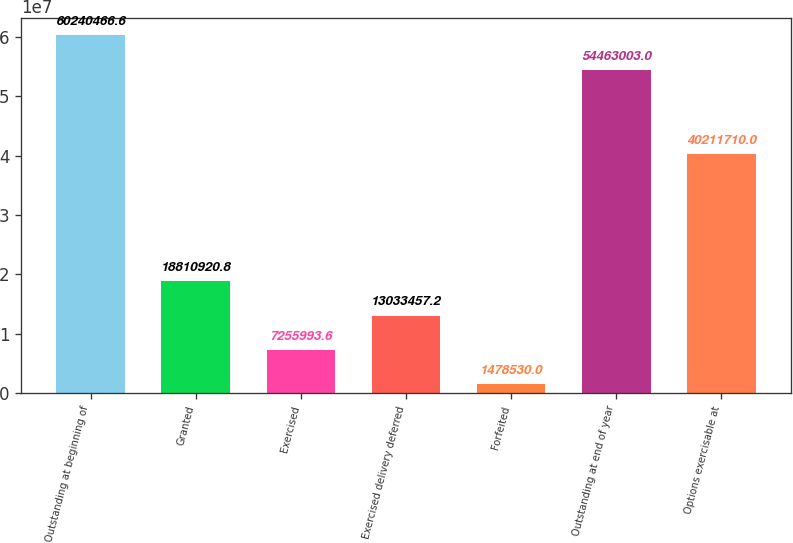Convert chart. <chart><loc_0><loc_0><loc_500><loc_500><bar_chart><fcel>Outstanding at beginning of<fcel>Granted<fcel>Exercised<fcel>Exercised delivery deferred<fcel>Forfeited<fcel>Outstanding at end of year<fcel>Options exercisable at<nl><fcel>6.02405e+07<fcel>1.88109e+07<fcel>7.25599e+06<fcel>1.30335e+07<fcel>1.47853e+06<fcel>5.4463e+07<fcel>4.02117e+07<nl></chart> 